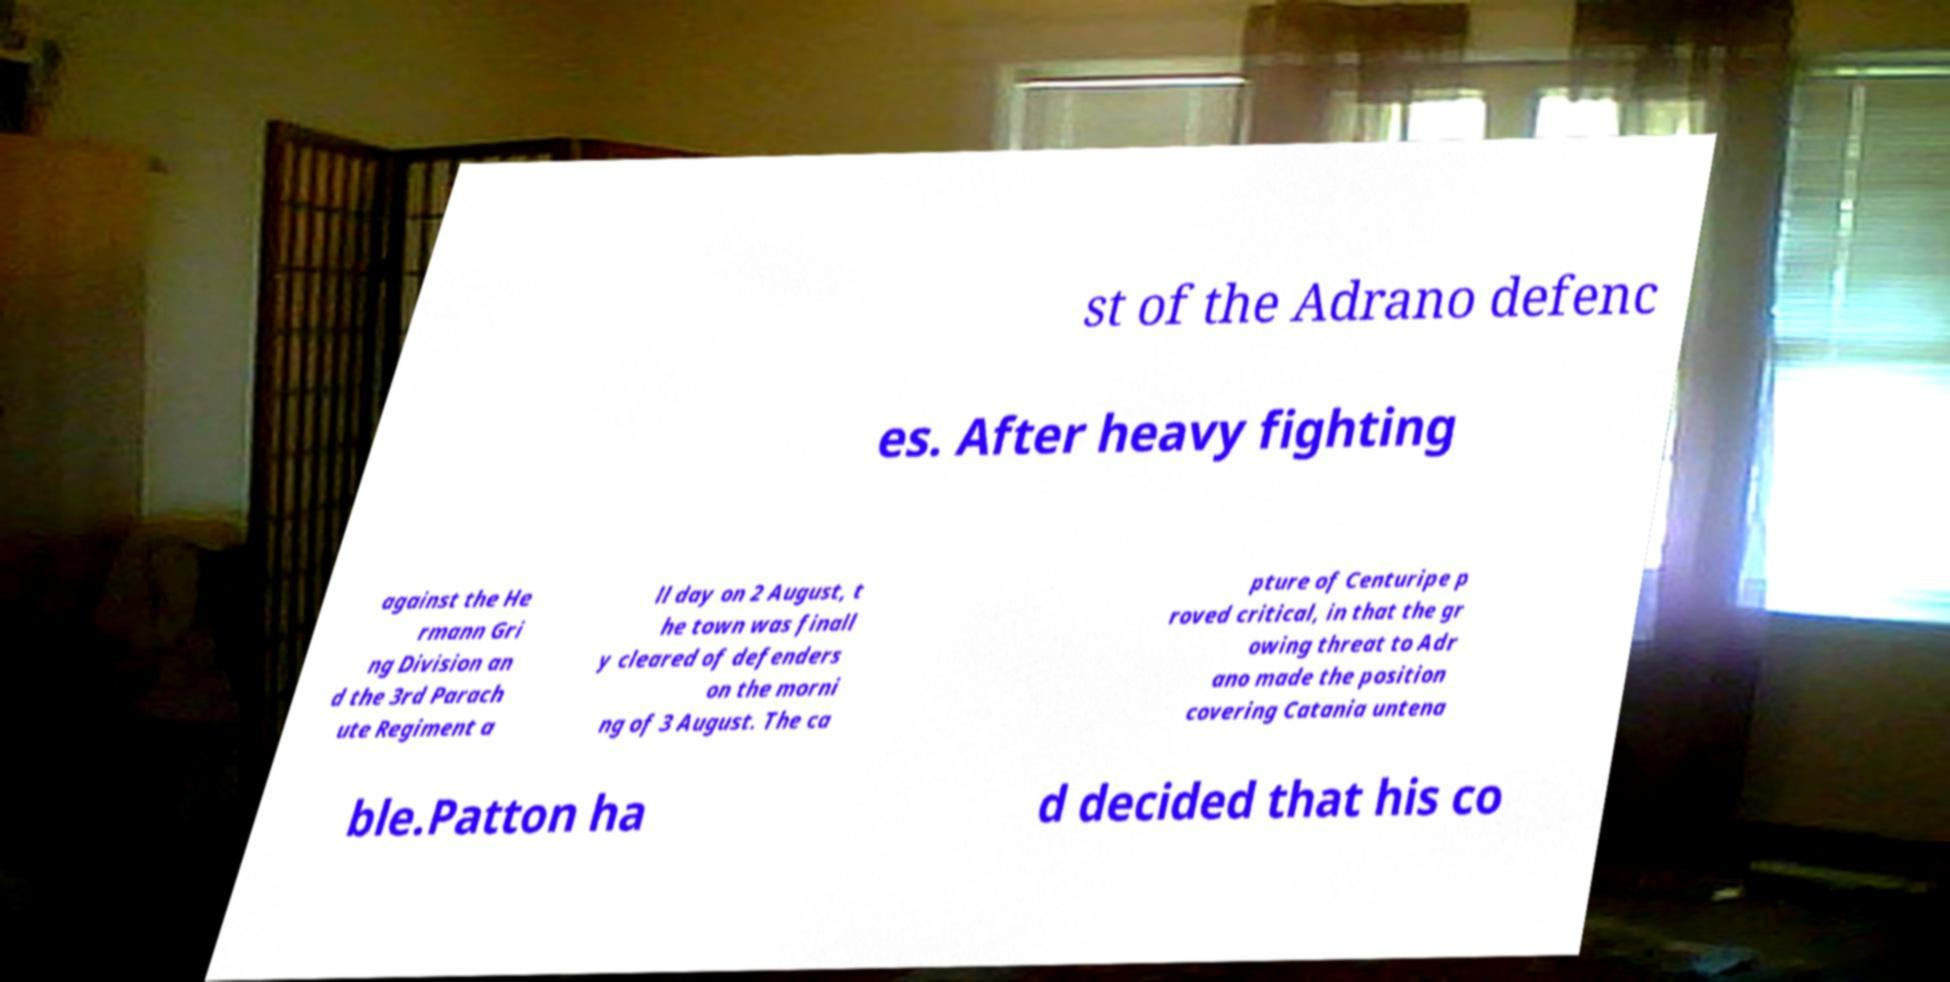What messages or text are displayed in this image? I need them in a readable, typed format. st of the Adrano defenc es. After heavy fighting against the He rmann Gri ng Division an d the 3rd Parach ute Regiment a ll day on 2 August, t he town was finall y cleared of defenders on the morni ng of 3 August. The ca pture of Centuripe p roved critical, in that the gr owing threat to Adr ano made the position covering Catania untena ble.Patton ha d decided that his co 